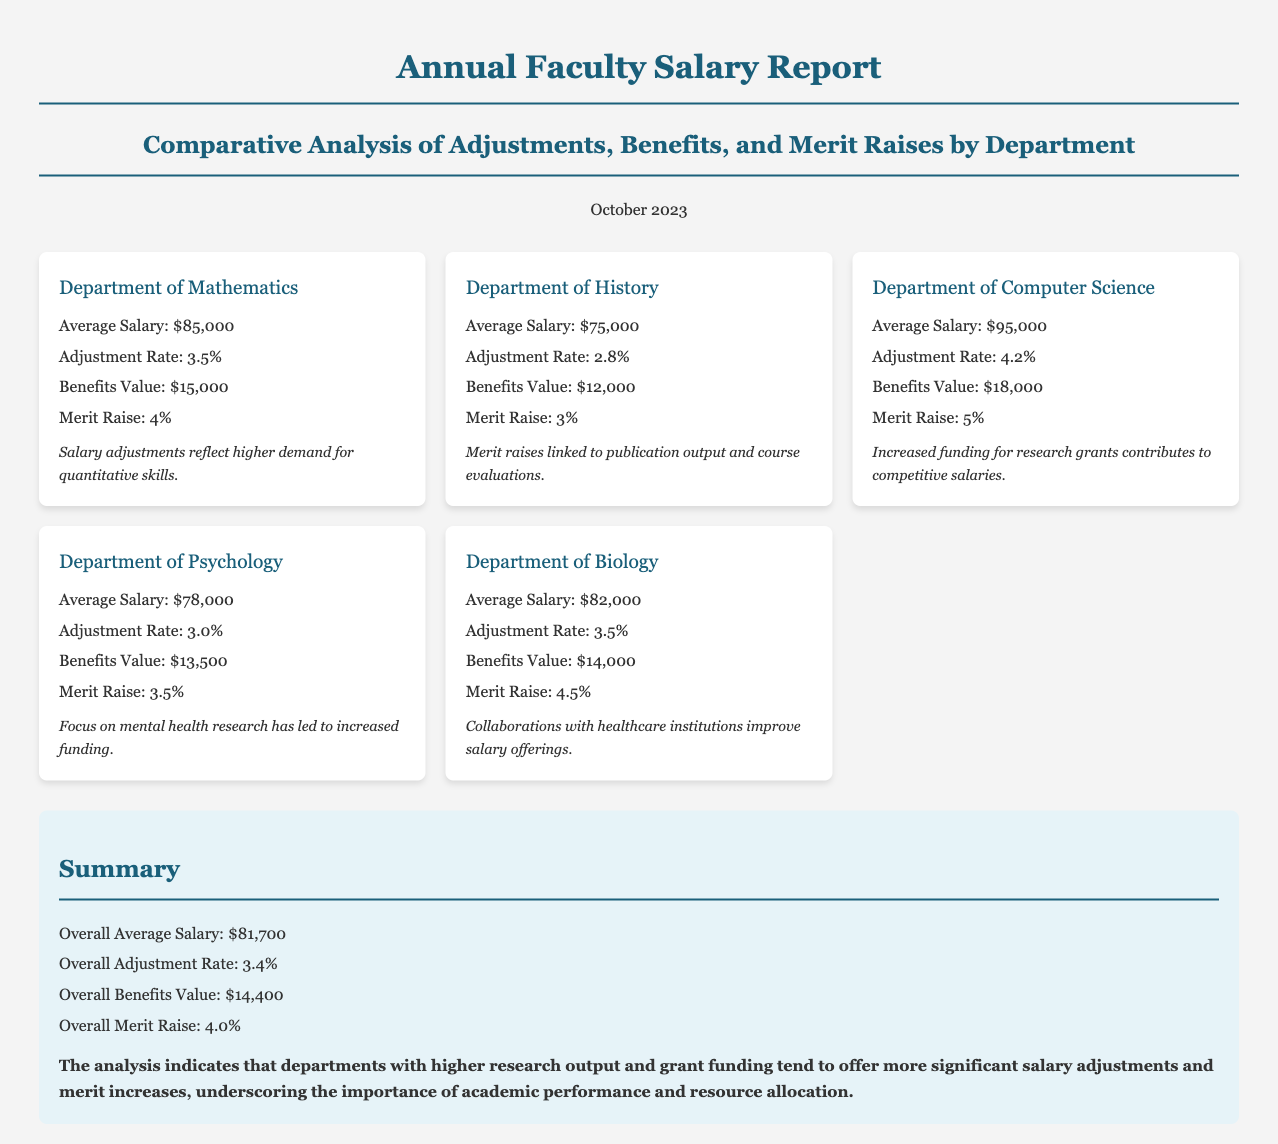What is the average salary of the Department of Mathematics? The average salary for the Department of Mathematics is explicitly stated in the document.
Answer: $85,000 What is the adjustment rate for the Department of Computer Science? The adjustment rate is a specific statistic provided for each department in the document.
Answer: 4.2% Which department has the highest benefits value? The benefits value is detailed for each department, allowing for comparison.
Answer: Department of Computer Science What is the overall average salary for all departments combined? The overall average salary is provided as a summary statistic at the end of the report.
Answer: $81,700 Which department received the highest merit raise? By analyzing the merit raise percentages listed for each department, we can identify the highest.
Answer: Department of Computer Science What is the adjustment rate difference between the Department of History and the Department of Psychology? This involves calculating the difference based on the adjustment rates provided for both departments.
Answer: 0.2% How much are benefits valued in the Department of Biology? The document lists the benefits value for each department explicitly.
Answer: $14,000 What conclusion does the report draw regarding departments with higher research output? The conclusion summarizes the overall findings of the report based on salary adjustments and merit raises.
Answer: Importance of academic performance and resource allocation 